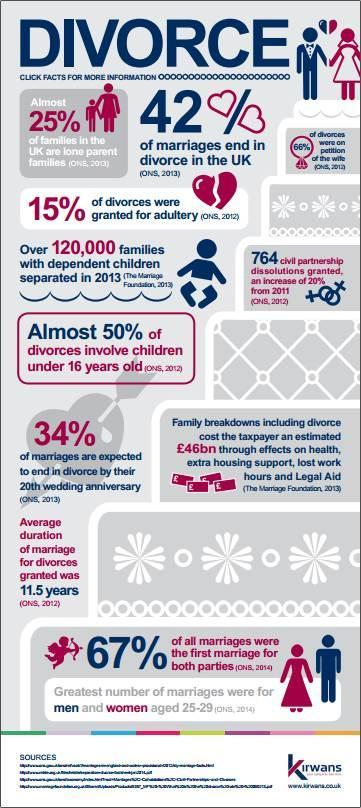What percentage of marriages in UK are not successful and ends in separation?
Answer the question with a short phrase. 42 What is the inverse of percentage of divorces which are allowed for adults? 85 What percentage of marriages in UK are successful? 58 